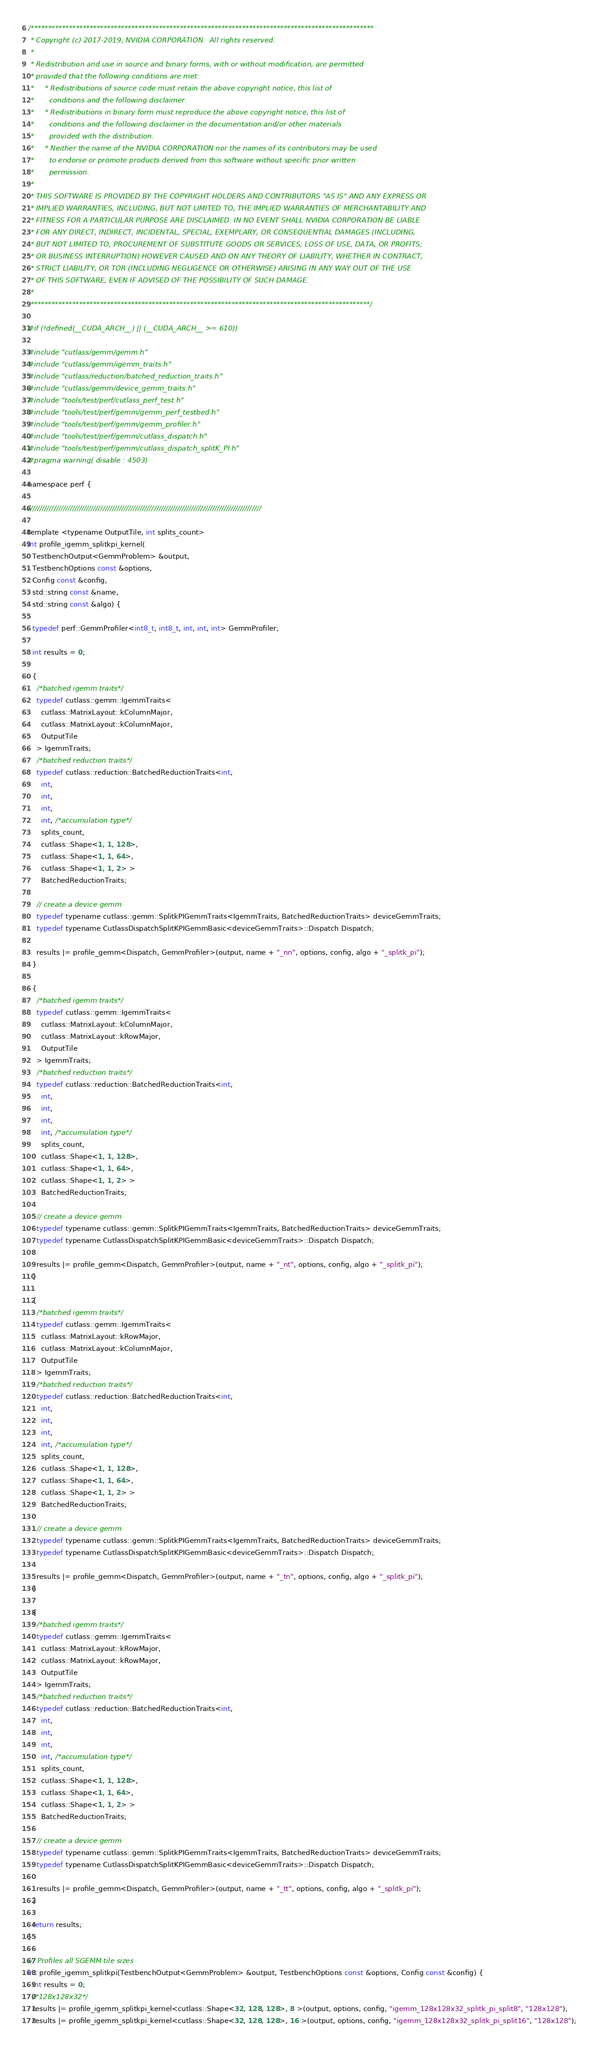Convert code to text. <code><loc_0><loc_0><loc_500><loc_500><_Cuda_>/***************************************************************************************************
 * Copyright (c) 2017-2019, NVIDIA CORPORATION.  All rights reserved.
 *
 * Redistribution and use in source and binary forms, with or without modification, are permitted
 * provided that the following conditions are met:
 *     * Redistributions of source code must retain the above copyright notice, this list of
 *       conditions and the following disclaimer.
 *     * Redistributions in binary form must reproduce the above copyright notice, this list of
 *       conditions and the following disclaimer in the documentation and/or other materials
 *       provided with the distribution.
 *     * Neither the name of the NVIDIA CORPORATION nor the names of its contributors may be used
 *       to endorse or promote products derived from this software without specific prior written
 *       permission.
 *
 * THIS SOFTWARE IS PROVIDED BY THE COPYRIGHT HOLDERS AND CONTRIBUTORS "AS IS" AND ANY EXPRESS OR
 * IMPLIED WARRANTIES, INCLUDING, BUT NOT LIMITED TO, THE IMPLIED WARRANTIES OF MERCHANTABILITY AND
 * FITNESS FOR A PARTICULAR PURPOSE ARE DISCLAIMED. IN NO EVENT SHALL NVIDIA CORPORATION BE LIABLE
 * FOR ANY DIRECT, INDIRECT, INCIDENTAL, SPECIAL, EXEMPLARY, OR CONSEQUENTIAL DAMAGES (INCLUDING,
 * BUT NOT LIMITED TO, PROCUREMENT OF SUBSTITUTE GOODS OR SERVICES; LOSS OF USE, DATA, OR PROFITS;
 * OR BUSINESS INTERRUPTION) HOWEVER CAUSED AND ON ANY THEORY OF LIABILITY, WHETHER IN CONTRACT,
 * STRICT LIABILITY, OR TOR (INCLUDING NEGLIGENCE OR OTHERWISE) ARISING IN ANY WAY OUT OF THE USE
 * OF THIS SOFTWARE, EVEN IF ADVISED OF THE POSSIBILITY OF SUCH DAMAGE.
 *
 **************************************************************************************************/

#if (!defined(__CUDA_ARCH__) || (__CUDA_ARCH__ >= 610))

#include "cutlass/gemm/gemm.h"
#include "cutlass/gemm/igemm_traits.h"
#include "cutlass/reduction/batched_reduction_traits.h"
#include "cutlass/gemm/device_gemm_traits.h"
#include "tools/test/perf/cutlass_perf_test.h"
#include "tools/test/perf/gemm/gemm_perf_testbed.h"
#include "tools/test/perf/gemm/gemm_profiler.h"
#include "tools/test/perf/gemm/cutlass_dispatch.h"
#include "tools/test/perf/gemm/cutlass_dispatch_splitK_PI.h"
#pragma warning( disable : 4503)

namespace perf {

////////////////////////////////////////////////////////////////////////////////////////////////////

template <typename OutputTile, int splits_count>
int profile_igemm_splitkpi_kernel(
  TestbenchOutput<GemmProblem> &output,
  TestbenchOptions const &options,
  Config const &config,
  std::string const &name,
  std::string const &algo) {

  typedef perf::GemmProfiler<int8_t, int8_t, int, int, int> GemmProfiler;

  int results = 0;

  {
    /*batched igemm traits*/
    typedef cutlass::gemm::IgemmTraits<
      cutlass::MatrixLayout::kColumnMajor,
      cutlass::MatrixLayout::kColumnMajor,
      OutputTile
    > IgemmTraits;
    /*batched reduction traits*/
    typedef cutlass::reduction::BatchedReductionTraits<int,
      int,
      int,
      int,
      int, /*accumulation type*/
      splits_count,
      cutlass::Shape<1, 1, 128>,
      cutlass::Shape<1, 1, 64>,
      cutlass::Shape<1, 1, 2> >
      BatchedReductionTraits;

    // create a device gemm 
    typedef typename cutlass::gemm::SplitkPIGemmTraits<IgemmTraits, BatchedReductionTraits> deviceGemmTraits;
    typedef typename CutlassDispatchSplitKPIGemmBasic<deviceGemmTraits>::Dispatch Dispatch;

    results |= profile_gemm<Dispatch, GemmProfiler>(output, name + "_nn", options, config, algo + "_splitk_pi");
  }

  {
    /*batched igemm traits*/
    typedef cutlass::gemm::IgemmTraits<
      cutlass::MatrixLayout::kColumnMajor,
      cutlass::MatrixLayout::kRowMajor,
      OutputTile
    > IgemmTraits;
    /*batched reduction traits*/
    typedef cutlass::reduction::BatchedReductionTraits<int,
      int,
      int,
      int,
      int, /*accumulation type*/
      splits_count,
      cutlass::Shape<1, 1, 128>,
      cutlass::Shape<1, 1, 64>,
      cutlass::Shape<1, 1, 2> >
      BatchedReductionTraits;

    // create a device gemm 
    typedef typename cutlass::gemm::SplitkPIGemmTraits<IgemmTraits, BatchedReductionTraits> deviceGemmTraits;
    typedef typename CutlassDispatchSplitKPIGemmBasic<deviceGemmTraits>::Dispatch Dispatch;

    results |= profile_gemm<Dispatch, GemmProfiler>(output, name + "_nt", options, config, algo + "_splitk_pi");
  }

  {
    /*batched igemm traits*/
    typedef cutlass::gemm::IgemmTraits<
      cutlass::MatrixLayout::kRowMajor,
      cutlass::MatrixLayout::kColumnMajor,
      OutputTile
    > IgemmTraits;
    /*batched reduction traits*/
    typedef cutlass::reduction::BatchedReductionTraits<int,
      int,
      int,
      int,
      int, /*accumulation type*/
      splits_count,
      cutlass::Shape<1, 1, 128>,
      cutlass::Shape<1, 1, 64>,
      cutlass::Shape<1, 1, 2> >
      BatchedReductionTraits;

    // create a device gemm 
    typedef typename cutlass::gemm::SplitkPIGemmTraits<IgemmTraits, BatchedReductionTraits> deviceGemmTraits;
    typedef typename CutlassDispatchSplitKPIGemmBasic<deviceGemmTraits>::Dispatch Dispatch;

    results |= profile_gemm<Dispatch, GemmProfiler>(output, name + "_tn", options, config, algo + "_splitk_pi");
  }

  {
    /*batched igemm traits*/
    typedef cutlass::gemm::IgemmTraits<
      cutlass::MatrixLayout::kRowMajor,
      cutlass::MatrixLayout::kRowMajor,
      OutputTile
    > IgemmTraits;
    /*batched reduction traits*/
    typedef cutlass::reduction::BatchedReductionTraits<int,
      int,
      int,
      int,
      int, /*accumulation type*/
      splits_count,
      cutlass::Shape<1, 1, 128>,
      cutlass::Shape<1, 1, 64>,
      cutlass::Shape<1, 1, 2> >
      BatchedReductionTraits;

    // create a device gemm 
    typedef typename cutlass::gemm::SplitkPIGemmTraits<IgemmTraits, BatchedReductionTraits> deviceGemmTraits;
    typedef typename CutlassDispatchSplitKPIGemmBasic<deviceGemmTraits>::Dispatch Dispatch;

    results |= profile_gemm<Dispatch, GemmProfiler>(output, name + "_tt", options, config, algo + "_splitk_pi");
  }

  return results;
}

/// Profiles all SGEMM tile sizes
int profile_igemm_splitkpi(TestbenchOutput<GemmProblem> &output, TestbenchOptions const &options, Config const &config) {
  int results = 0;
  /*128x128x32*/
  results |= profile_igemm_splitkpi_kernel<cutlass::Shape<32, 128, 128>, 8 >(output, options, config, "igemm_128x128x32_splitk_pi_split8", "128x128");
  results |= profile_igemm_splitkpi_kernel<cutlass::Shape<32, 128, 128>, 16 >(output, options, config, "igemm_128x128x32_splitk_pi_split16", "128x128");</code> 